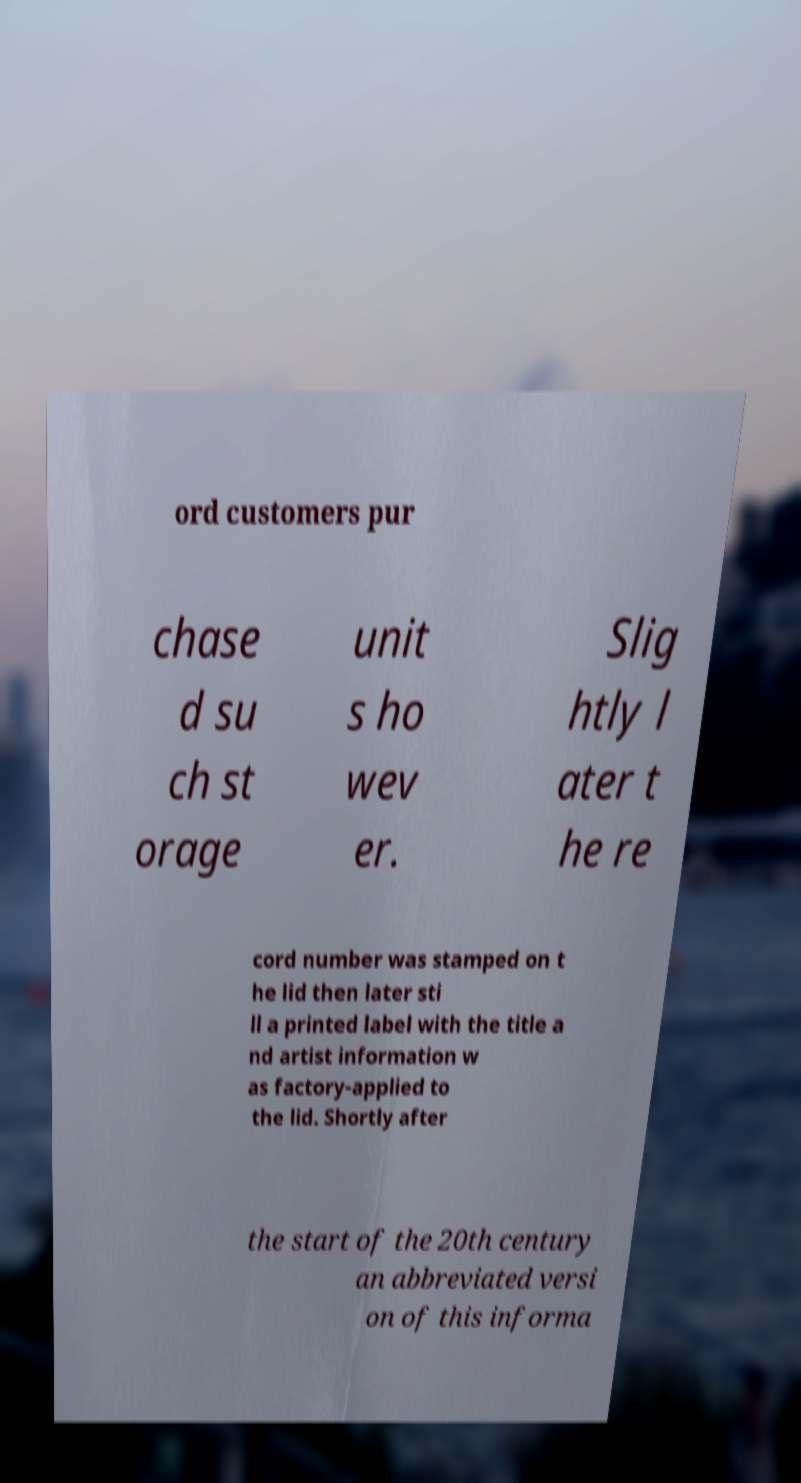I need the written content from this picture converted into text. Can you do that? ord customers pur chase d su ch st orage unit s ho wev er. Slig htly l ater t he re cord number was stamped on t he lid then later sti ll a printed label with the title a nd artist information w as factory-applied to the lid. Shortly after the start of the 20th century an abbreviated versi on of this informa 